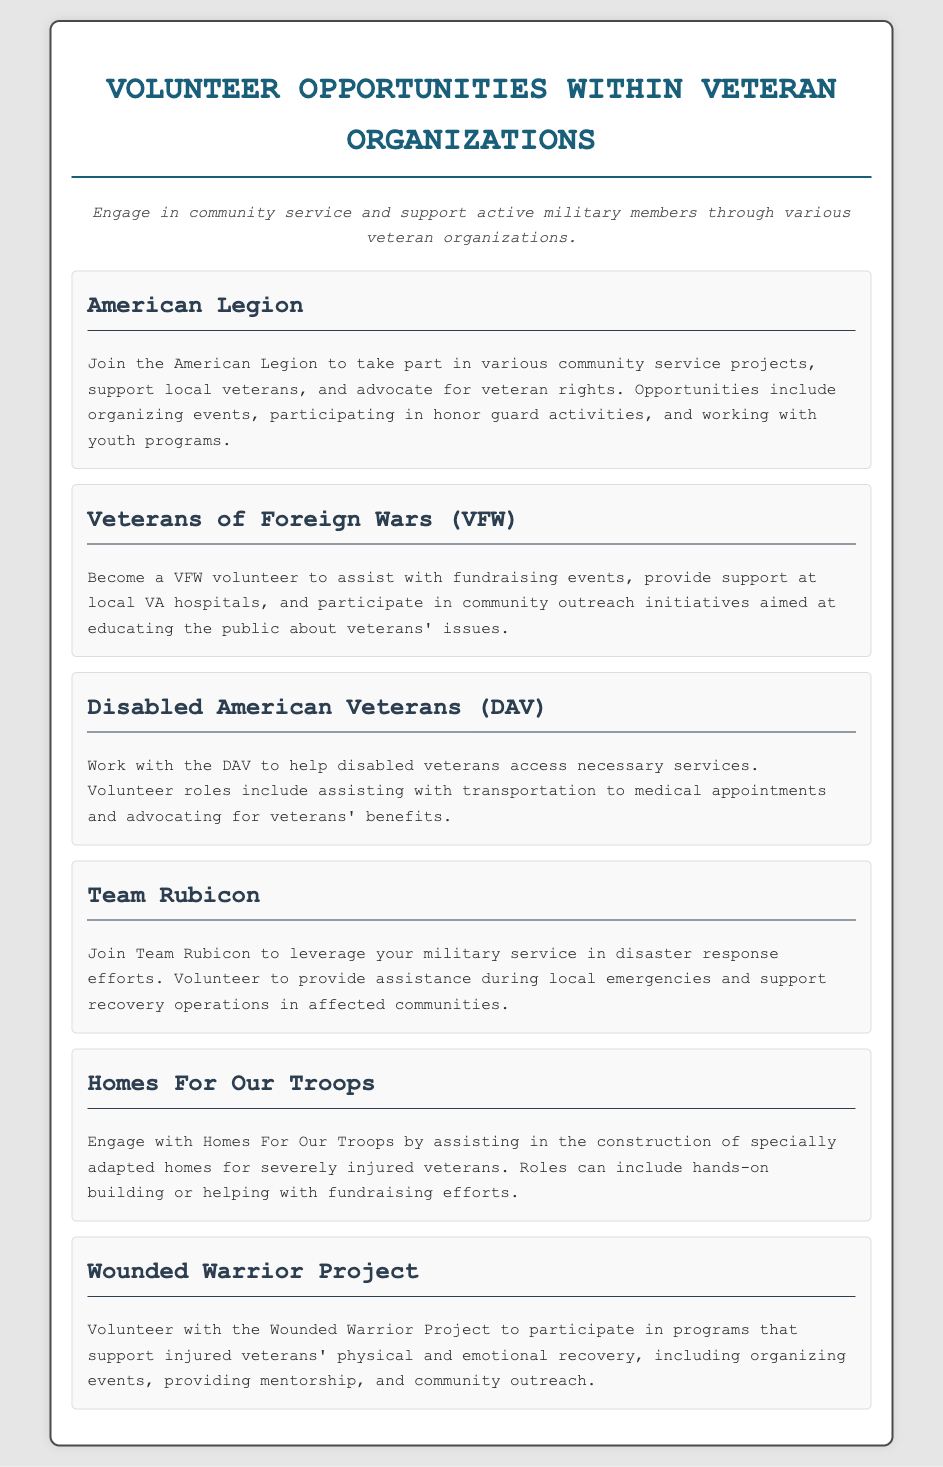What organization helps disabled veterans? The document mentions the Disabled American Veterans (DAV) as supporting disabled veterans.
Answer: Disabled American Veterans What is a volunteer opportunity with the American Legion? The American Legion offers various community service projects and organizing events as volunteer opportunities.
Answer: Organizing events How does Team Rubicon help communities? Team Rubicon volunteers provide assistance during local emergencies and support recovery operations.
Answer: Disaster response What is the main focus of the Wounded Warrior Project? The Wounded Warrior Project focuses on supporting injured veterans' physical and emotional recovery.
Answer: Recovery In what organization can one assist with building homes for veterans? The document specifies Homes For Our Troops as the organization for assisting in the construction of homes.
Answer: Homes For Our Troops What type of activities do VFW volunteers participate in? VFW volunteers participate in fundraising events and community outreach initiatives.
Answer: Fundraising events How many organizations are listed in the document? The document lists six different veteran organizations.
Answer: Six What common theme do all the organizations in the document promote? The common theme among all organizations is supporting veterans and active military members through community service.
Answer: Support for veterans 